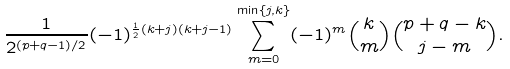Convert formula to latex. <formula><loc_0><loc_0><loc_500><loc_500>\frac { 1 } { 2 ^ { ( p + q - 1 ) / 2 } } ( - 1 ) ^ { \frac { 1 } { 2 } ( k + j ) ( k + j - 1 ) } \sum _ { m = 0 } ^ { \min \{ j , k \} } ( - 1 ) ^ { m } { k \choose m } { p + q - k \choose j - m } .</formula> 